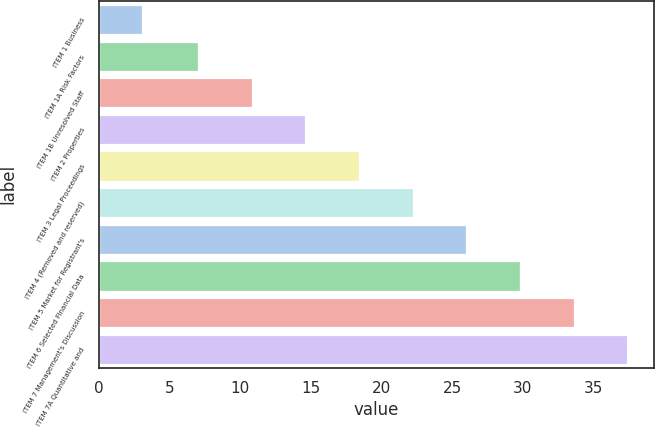Convert chart. <chart><loc_0><loc_0><loc_500><loc_500><bar_chart><fcel>ITEM 1 Business<fcel>ITEM 1A Risk Factors<fcel>ITEM 1B Unresolved Staff<fcel>ITEM 2 Properties<fcel>ITEM 3 Legal Proceedings<fcel>ITEM 4 (Removed and reserved)<fcel>ITEM 5 Market for Registrant's<fcel>ITEM 6 Selected Financial Data<fcel>ITEM 7 Management's Discussion<fcel>ITEM 7A Quantitative and<nl><fcel>3<fcel>7<fcel>10.8<fcel>14.6<fcel>18.4<fcel>22.2<fcel>26<fcel>29.8<fcel>33.6<fcel>37.4<nl></chart> 